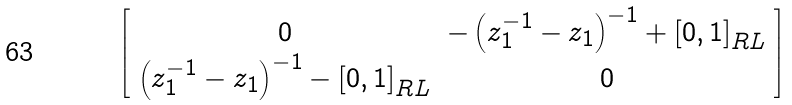Convert formula to latex. <formula><loc_0><loc_0><loc_500><loc_500>\left [ \begin{array} { c c } 0 & - \left ( z _ { 1 } ^ { - 1 } - z _ { 1 } \right ) ^ { - 1 } + \left [ 0 , 1 \right ] _ { R L } \\ \left ( z _ { 1 } ^ { - 1 } - z _ { 1 } \right ) ^ { - 1 } - \left [ 0 , 1 \right ] _ { R L } & 0 \end{array} \right ]</formula> 